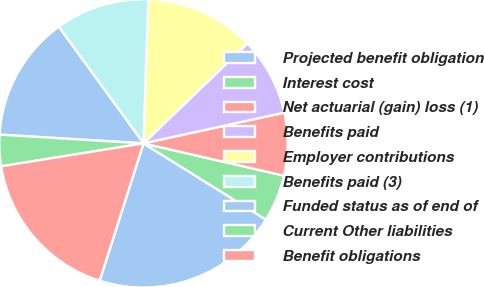Convert chart. <chart><loc_0><loc_0><loc_500><loc_500><pie_chart><fcel>Projected benefit obligation<fcel>Interest cost<fcel>Net actuarial (gain) loss (1)<fcel>Benefits paid<fcel>Employer contributions<fcel>Benefits paid (3)<fcel>Funded status as of end of<fcel>Current Other liabilities<fcel>Benefit obligations<nl><fcel>21.05%<fcel>5.27%<fcel>7.02%<fcel>8.77%<fcel>12.28%<fcel>10.53%<fcel>14.03%<fcel>3.51%<fcel>17.54%<nl></chart> 